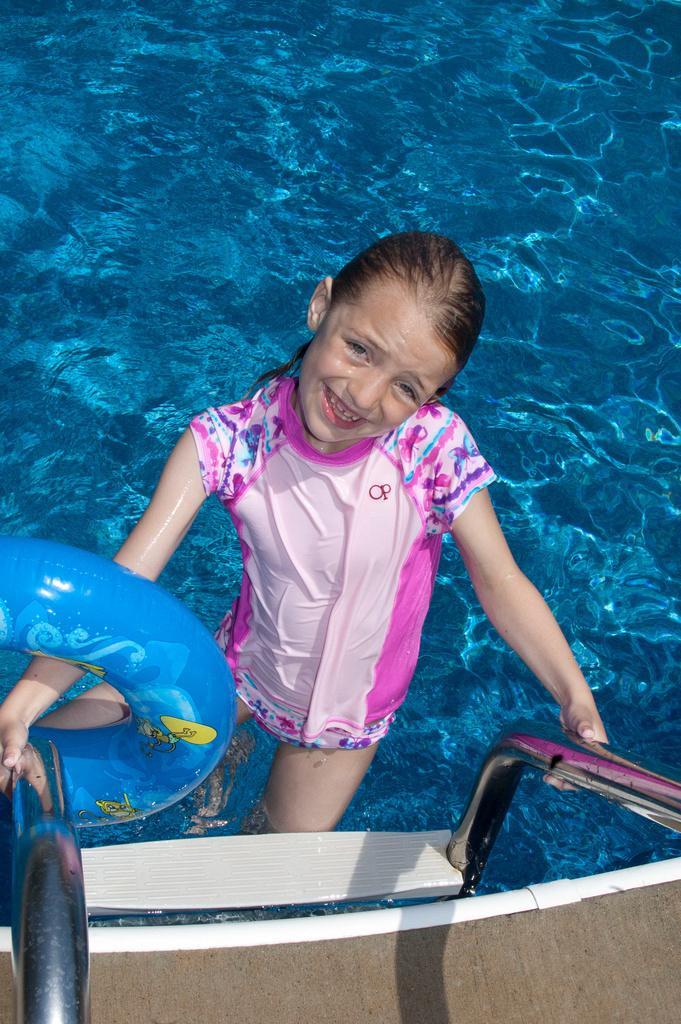How would you summarize this image in a sentence or two? In this image there is a girl smiling and she is present in the swimming pool. Image also consists of a safety ring. 